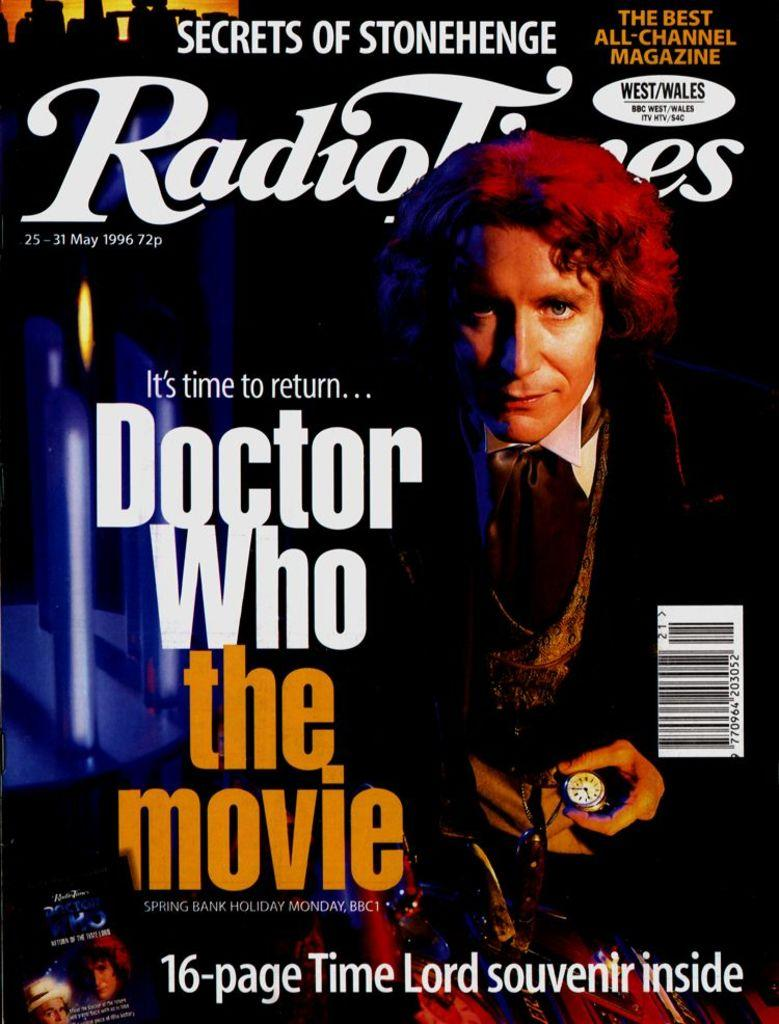<image>
Relay a brief, clear account of the picture shown. A copy of RadioTimes with an article about Doctor Who the movie inside. 